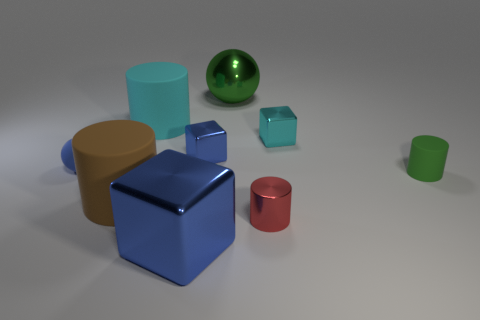Subtract all tiny cyan metallic blocks. How many blocks are left? 2 Subtract all green cylinders. How many cylinders are left? 3 Subtract 3 cylinders. How many cylinders are left? 1 Add 1 cyan cubes. How many objects exist? 10 Subtract all cubes. How many objects are left? 6 Subtract all green rubber cylinders. Subtract all tiny metal cylinders. How many objects are left? 7 Add 8 large blue cubes. How many large blue cubes are left? 9 Add 6 large cyan rubber things. How many large cyan rubber things exist? 7 Subtract 1 green balls. How many objects are left? 8 Subtract all gray cylinders. Subtract all yellow blocks. How many cylinders are left? 4 